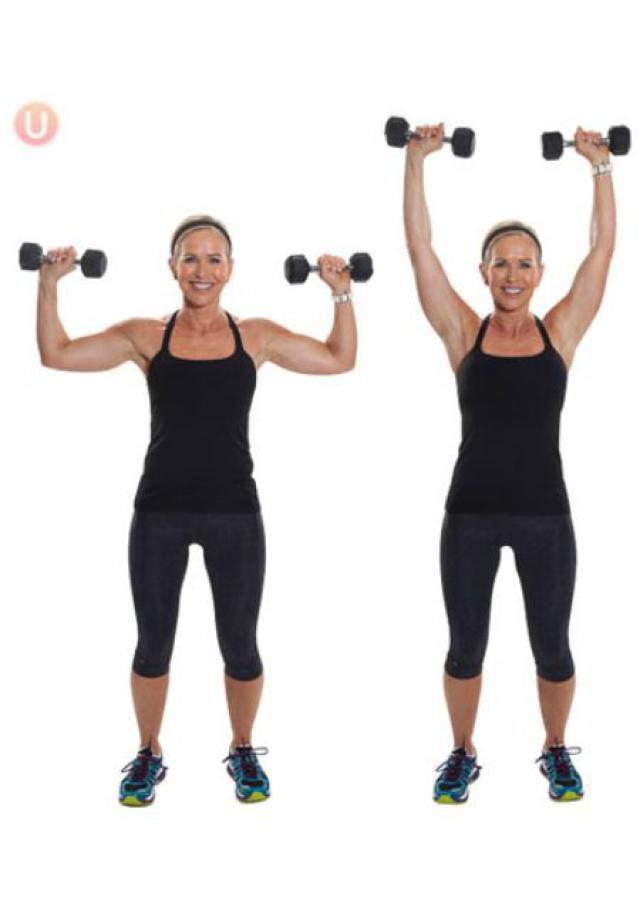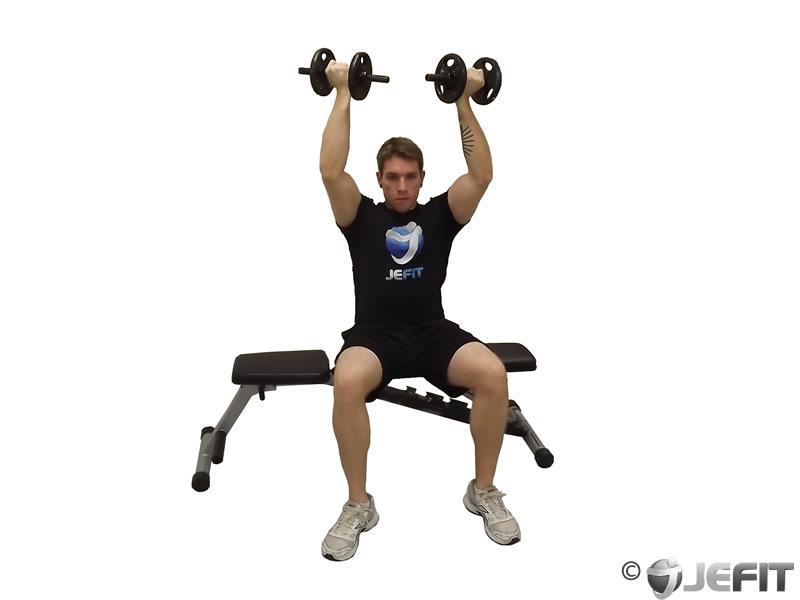The first image is the image on the left, the second image is the image on the right. Analyze the images presented: Is the assertion "The left image shows a female working out." valid? Answer yes or no. Yes. 